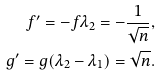<formula> <loc_0><loc_0><loc_500><loc_500>f ^ { \prime } = - f \lambda _ { 2 } = - \frac { 1 } { \sqrt { n } } , \\ g ^ { \prime } = g ( \lambda _ { 2 } - \lambda _ { 1 } ) = \sqrt { n } .</formula> 